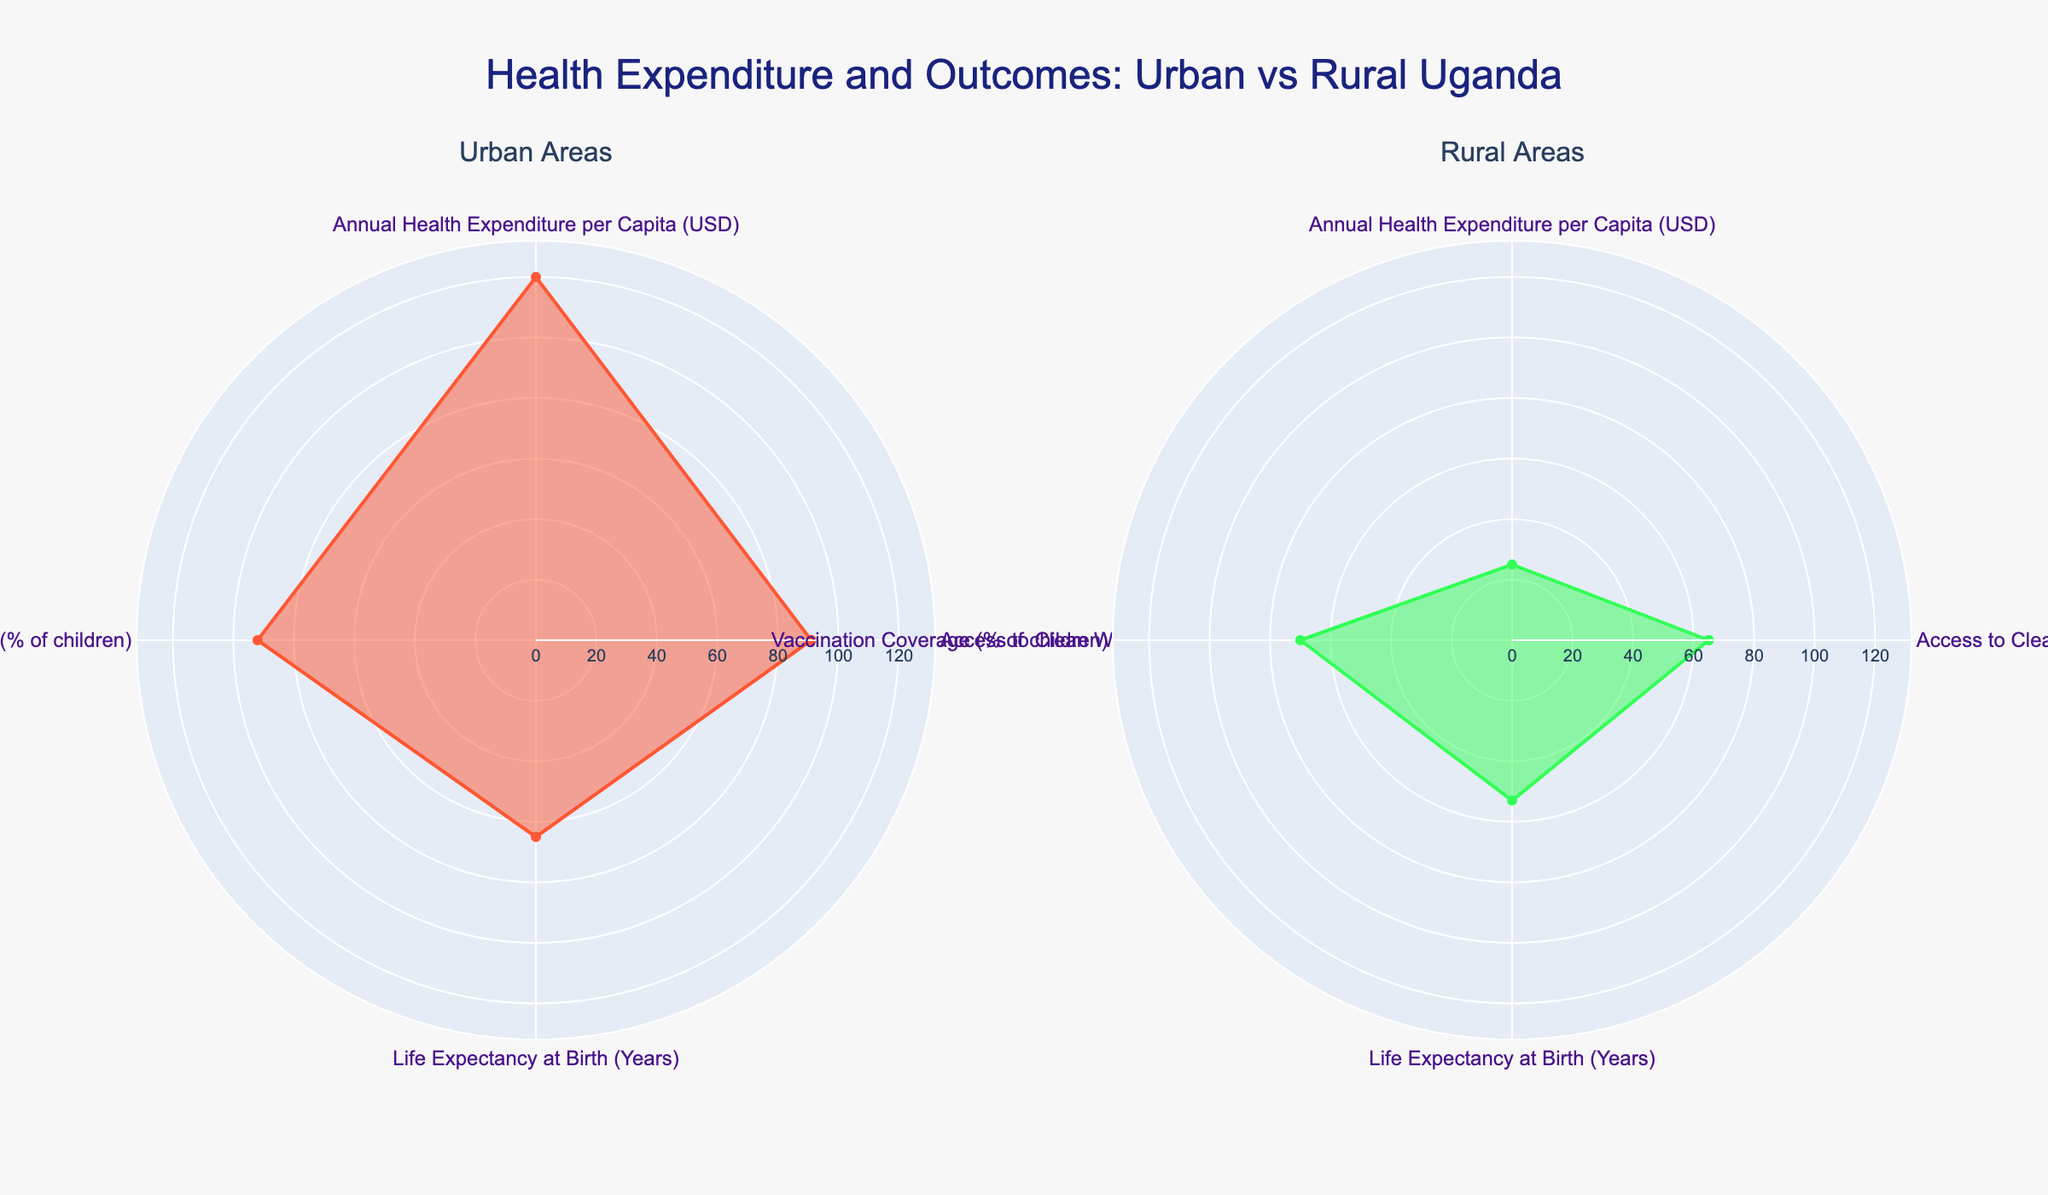What is the title of the figure? The title is typically displayed at the top of the figure. In this case, the title of the figure is "Health Expenditure and Outcomes: Urban vs Rural Uganda".
Answer: Health Expenditure and Outcomes: Urban vs Rural Uganda Which area shows higher access to clean water? By comparing the values for access to clean water (% of population) in the radar charts, Urban areas show 91% whereas Rural areas show 65%.
Answer: Urban What is the difference in annual health expenditure per capita between Urban and Rural areas? Urban areas have an annual health expenditure per capita of 120 USD, and Rural areas have 25 USD. The difference is 120 - 25 = 95 USD.
Answer: 95 USD Which category shows the smallest difference between Urban and Rural? To determine this, we compare the difference in values for each category between Urban and Rural: 
- Access to Clean Water: 91 - 65 = 26 
- Annual Health Expenditure: 120 - 25 = 95 
- Vaccination Coverage: 92 - 70 = 22 
- Life Expectancy: 65 - 53 = 12 
The smallest difference is in Life Expectancy.
Answer: Life Expectancy What is the highest value for any category in Rural areas? By examining all the values for Rural areas, the highest value is for Vaccination Coverage at 70%.
Answer: 70% What is the average life expectancy at birth across both Urban and Rural areas? The life expectancy in Urban areas is 65 years, and in Rural areas, it is 53 years. The average is (65 + 53) / 2 = 59 years.
Answer: 59 years Which area shows the highest vaccination coverage? Comparing the vaccination coverage percentages, Urban areas have 92% coverage, whereas Rural areas have 70%. So Urban areas show the highest vaccination coverage.
Answer: Urban By how much does life expectancy in Urban areas exceed that in Rural areas? Urban life expectancy is 65 years, while Rural life expectancy is 53 years. The difference is 65 - 53 = 12 years.
Answer: 12 years 